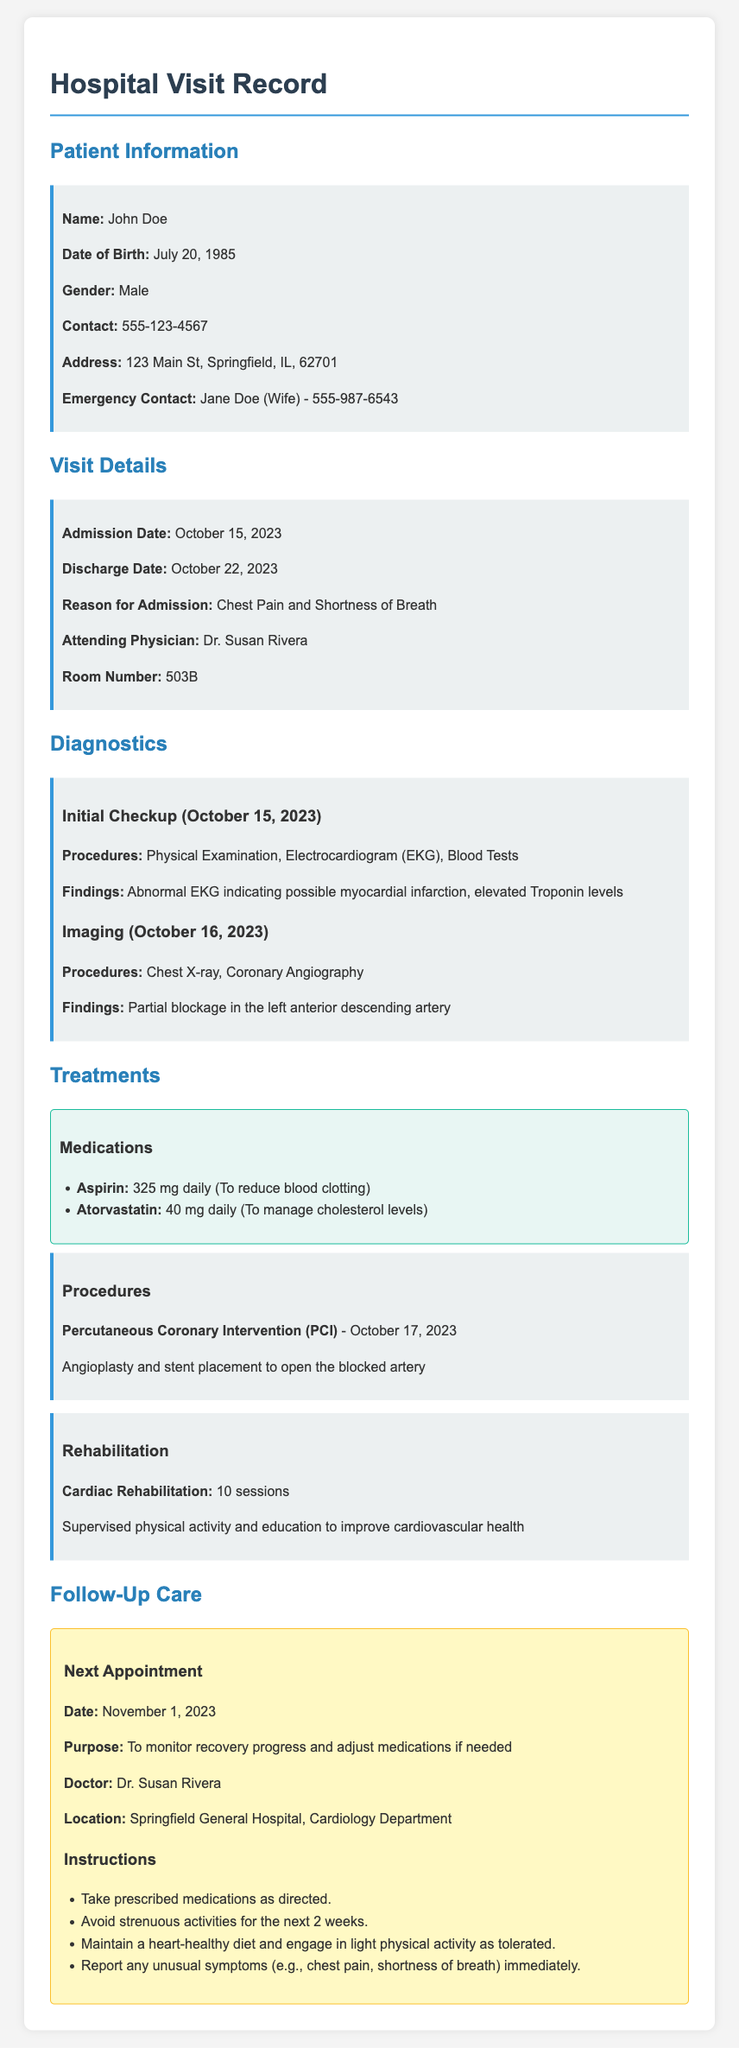What is the patient's name? The patient's name is listed under Patient Information.
Answer: John Doe What was the admission date? The admission date is specified in the Visit Details section.
Answer: October 15, 2023 Who was the attending physician? The attending physician's name is provided in the Visit Details.
Answer: Dr. Susan Rivera What diagnostic procedures were performed on October 15, 2023? The diagnostic procedures for that date are listed under Diagnostics.
Answer: Physical Examination, Electrocardiogram (EKG), Blood Tests What treatment was performed on October 17, 2023? The treatment date and type are mentioned in the Treatments section.
Answer: Percutaneous Coronary Intervention (PCI) How many cardiac rehabilitation sessions are required? This information can be found in the Treatments section under Rehabilitation.
Answer: 10 sessions What is the date of the next appointment? The date is provided in the Follow-Up Care section.
Answer: November 1, 2023 What should the patient do if they experience unusual symptoms? This instruction is listed in the Follow-Up Care section.
Answer: Report immediately What medications were prescribed? The prescribed medications are listed under the Treatments section.
Answer: Aspirin, Atorvastatin 